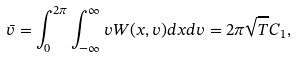<formula> <loc_0><loc_0><loc_500><loc_500>\bar { v } = \int _ { 0 } ^ { 2 \pi } \int _ { - \infty } ^ { \infty } v W ( x , v ) d x d v = 2 \pi \sqrt { T } C _ { 1 } ,</formula> 